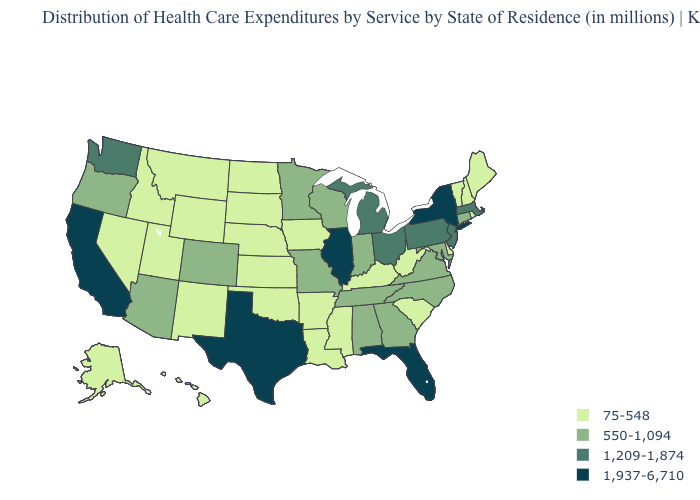What is the highest value in states that border Idaho?
Keep it brief. 1,209-1,874. Which states have the lowest value in the West?
Be succinct. Alaska, Hawaii, Idaho, Montana, Nevada, New Mexico, Utah, Wyoming. Name the states that have a value in the range 75-548?
Concise answer only. Alaska, Arkansas, Delaware, Hawaii, Idaho, Iowa, Kansas, Kentucky, Louisiana, Maine, Mississippi, Montana, Nebraska, Nevada, New Hampshire, New Mexico, North Dakota, Oklahoma, Rhode Island, South Carolina, South Dakota, Utah, Vermont, West Virginia, Wyoming. Does South Dakota have the same value as Massachusetts?
Keep it brief. No. What is the value of New Hampshire?
Write a very short answer. 75-548. Which states have the highest value in the USA?
Short answer required. California, Florida, Illinois, New York, Texas. Name the states that have a value in the range 550-1,094?
Write a very short answer. Alabama, Arizona, Colorado, Connecticut, Georgia, Indiana, Maryland, Minnesota, Missouri, North Carolina, Oregon, Tennessee, Virginia, Wisconsin. What is the value of Idaho?
Quick response, please. 75-548. Name the states that have a value in the range 1,937-6,710?
Give a very brief answer. California, Florida, Illinois, New York, Texas. What is the value of South Dakota?
Quick response, please. 75-548. What is the value of Kansas?
Be succinct. 75-548. Among the states that border Michigan , does Indiana have the lowest value?
Be succinct. Yes. Among the states that border Kansas , which have the lowest value?
Keep it brief. Nebraska, Oklahoma. Does the first symbol in the legend represent the smallest category?
Quick response, please. Yes. What is the value of New Mexico?
Keep it brief. 75-548. 